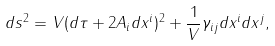<formula> <loc_0><loc_0><loc_500><loc_500>d s ^ { 2 } = V ( d \tau + 2 A _ { i } d x ^ { i } ) ^ { 2 } + \frac { 1 } { V } \gamma _ { i j } d x ^ { i } d x ^ { j } ,</formula> 